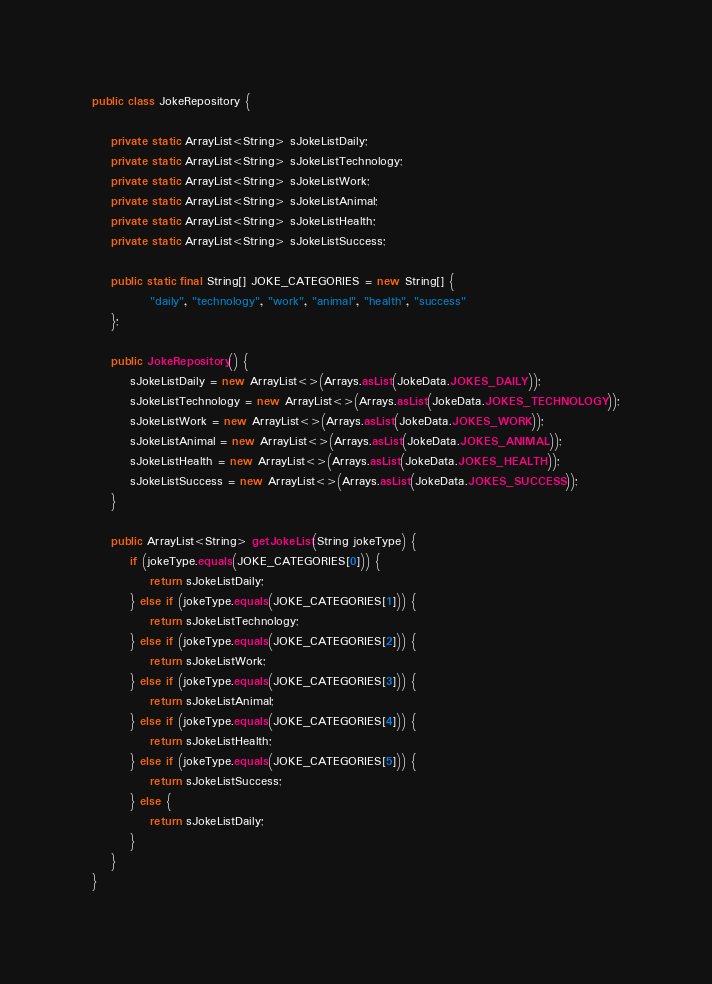Convert code to text. <code><loc_0><loc_0><loc_500><loc_500><_Java_>public class JokeRepository {

    private static ArrayList<String> sJokeListDaily;
    private static ArrayList<String> sJokeListTechnology;
    private static ArrayList<String> sJokeListWork;
    private static ArrayList<String> sJokeListAnimal;
    private static ArrayList<String> sJokeListHealth;
    private static ArrayList<String> sJokeListSuccess;

    public static final String[] JOKE_CATEGORIES = new String[] {
            "daily", "technology", "work", "animal", "health", "success"
    };

    public JokeRepository() {
        sJokeListDaily = new ArrayList<>(Arrays.asList(JokeData.JOKES_DAILY));
        sJokeListTechnology = new ArrayList<>(Arrays.asList(JokeData.JOKES_TECHNOLOGY));
        sJokeListWork = new ArrayList<>(Arrays.asList(JokeData.JOKES_WORK));
        sJokeListAnimal = new ArrayList<>(Arrays.asList(JokeData.JOKES_ANIMAL));
        sJokeListHealth = new ArrayList<>(Arrays.asList(JokeData.JOKES_HEALTH));
        sJokeListSuccess = new ArrayList<>(Arrays.asList(JokeData.JOKES_SUCCESS));
    }

    public ArrayList<String> getJokeList(String jokeType) {
        if (jokeType.equals(JOKE_CATEGORIES[0])) {
            return sJokeListDaily;
        } else if (jokeType.equals(JOKE_CATEGORIES[1])) {
            return sJokeListTechnology;
        } else if (jokeType.equals(JOKE_CATEGORIES[2])) {
            return sJokeListWork;
        } else if (jokeType.equals(JOKE_CATEGORIES[3])) {
            return sJokeListAnimal;
        } else if (jokeType.equals(JOKE_CATEGORIES[4])) {
            return sJokeListHealth;
        } else if (jokeType.equals(JOKE_CATEGORIES[5])) {
            return sJokeListSuccess;
        } else {
            return sJokeListDaily;
        }
    }
}
</code> 